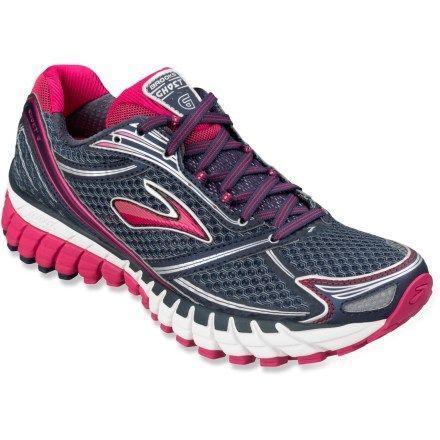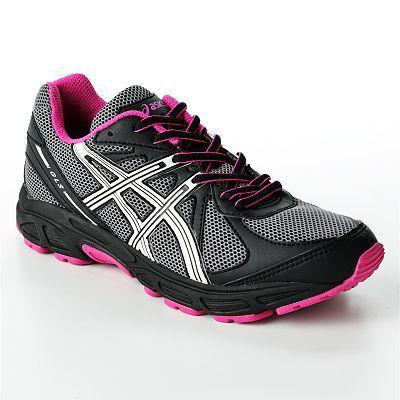The first image is the image on the left, the second image is the image on the right. For the images displayed, is the sentence "At least one shoe in the image on the right has pink laces." factually correct? Answer yes or no. No. 